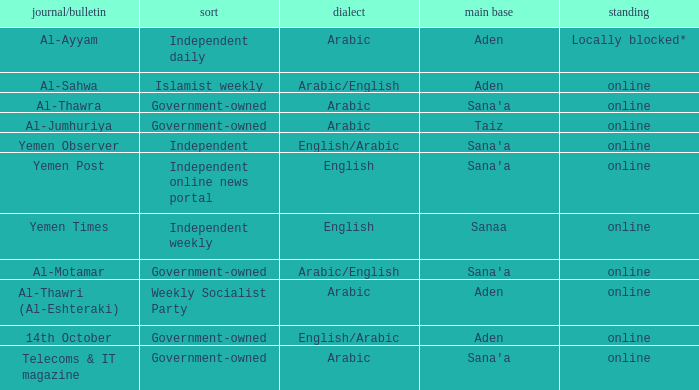What is Headquarter, when Newspaper/Magazine is Al-Ayyam? Aden. 